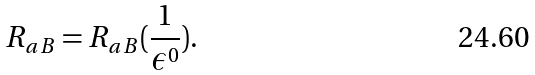<formula> <loc_0><loc_0><loc_500><loc_500>R _ { a B } = R _ { a B } ( \frac { 1 } { \epsilon ^ { 0 } } ) .</formula> 